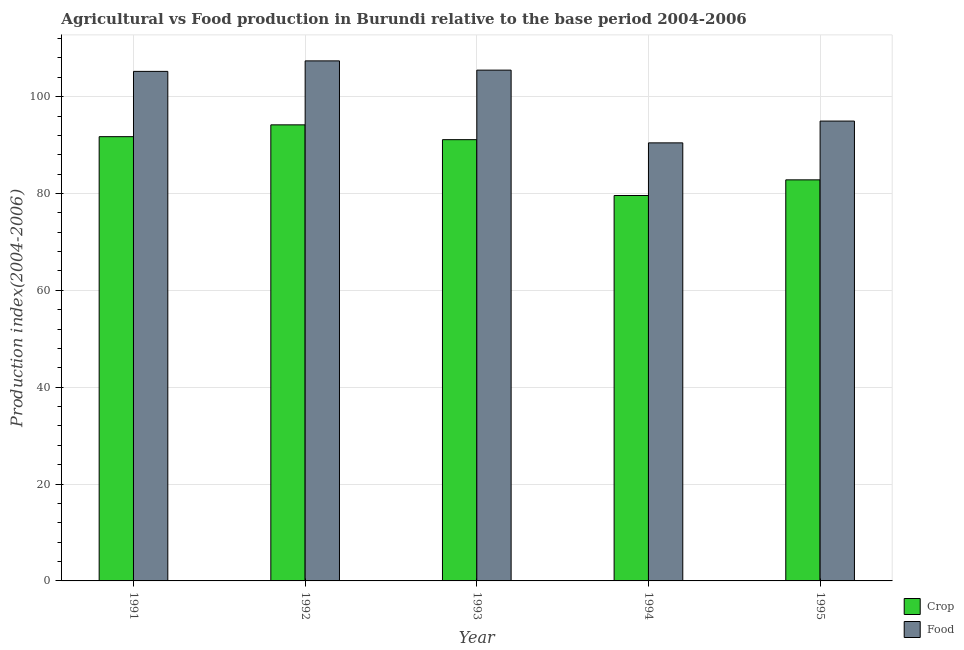How many different coloured bars are there?
Ensure brevity in your answer.  2. Are the number of bars per tick equal to the number of legend labels?
Offer a very short reply. Yes. Are the number of bars on each tick of the X-axis equal?
Provide a short and direct response. Yes. How many bars are there on the 1st tick from the right?
Provide a succinct answer. 2. What is the label of the 1st group of bars from the left?
Your response must be concise. 1991. What is the food production index in 1994?
Your answer should be very brief. 90.46. Across all years, what is the maximum crop production index?
Make the answer very short. 94.18. Across all years, what is the minimum food production index?
Offer a terse response. 90.46. In which year was the crop production index minimum?
Your response must be concise. 1994. What is the total crop production index in the graph?
Your answer should be very brief. 439.45. What is the difference between the crop production index in 1991 and that in 1994?
Provide a succinct answer. 12.15. What is the difference between the food production index in 1991 and the crop production index in 1993?
Give a very brief answer. -0.26. What is the average food production index per year?
Give a very brief answer. 100.7. In the year 1995, what is the difference between the crop production index and food production index?
Ensure brevity in your answer.  0. What is the ratio of the crop production index in 1992 to that in 1993?
Offer a terse response. 1.03. Is the difference between the crop production index in 1992 and 1994 greater than the difference between the food production index in 1992 and 1994?
Provide a succinct answer. No. What is the difference between the highest and the second highest food production index?
Your answer should be compact. 1.91. What is the difference between the highest and the lowest crop production index?
Give a very brief answer. 14.59. In how many years, is the food production index greater than the average food production index taken over all years?
Your answer should be compact. 3. What does the 1st bar from the left in 1991 represents?
Give a very brief answer. Crop. What does the 1st bar from the right in 1992 represents?
Your answer should be very brief. Food. Are all the bars in the graph horizontal?
Give a very brief answer. No. What is the difference between two consecutive major ticks on the Y-axis?
Your answer should be very brief. 20. Are the values on the major ticks of Y-axis written in scientific E-notation?
Give a very brief answer. No. Does the graph contain any zero values?
Ensure brevity in your answer.  No. Does the graph contain grids?
Offer a very short reply. Yes. Where does the legend appear in the graph?
Your answer should be very brief. Bottom right. How are the legend labels stacked?
Ensure brevity in your answer.  Vertical. What is the title of the graph?
Provide a succinct answer. Agricultural vs Food production in Burundi relative to the base period 2004-2006. What is the label or title of the X-axis?
Your answer should be very brief. Year. What is the label or title of the Y-axis?
Ensure brevity in your answer.  Production index(2004-2006). What is the Production index(2004-2006) in Crop in 1991?
Provide a short and direct response. 91.74. What is the Production index(2004-2006) of Food in 1991?
Keep it short and to the point. 105.22. What is the Production index(2004-2006) in Crop in 1992?
Your response must be concise. 94.18. What is the Production index(2004-2006) of Food in 1992?
Provide a succinct answer. 107.39. What is the Production index(2004-2006) of Crop in 1993?
Keep it short and to the point. 91.12. What is the Production index(2004-2006) in Food in 1993?
Ensure brevity in your answer.  105.48. What is the Production index(2004-2006) in Crop in 1994?
Give a very brief answer. 79.59. What is the Production index(2004-2006) in Food in 1994?
Ensure brevity in your answer.  90.46. What is the Production index(2004-2006) of Crop in 1995?
Provide a succinct answer. 82.82. What is the Production index(2004-2006) in Food in 1995?
Make the answer very short. 94.96. Across all years, what is the maximum Production index(2004-2006) in Crop?
Provide a short and direct response. 94.18. Across all years, what is the maximum Production index(2004-2006) of Food?
Keep it short and to the point. 107.39. Across all years, what is the minimum Production index(2004-2006) in Crop?
Provide a short and direct response. 79.59. Across all years, what is the minimum Production index(2004-2006) in Food?
Provide a succinct answer. 90.46. What is the total Production index(2004-2006) of Crop in the graph?
Offer a very short reply. 439.45. What is the total Production index(2004-2006) in Food in the graph?
Offer a very short reply. 503.51. What is the difference between the Production index(2004-2006) of Crop in 1991 and that in 1992?
Keep it short and to the point. -2.44. What is the difference between the Production index(2004-2006) of Food in 1991 and that in 1992?
Give a very brief answer. -2.17. What is the difference between the Production index(2004-2006) of Crop in 1991 and that in 1993?
Your answer should be compact. 0.62. What is the difference between the Production index(2004-2006) in Food in 1991 and that in 1993?
Offer a terse response. -0.26. What is the difference between the Production index(2004-2006) in Crop in 1991 and that in 1994?
Provide a short and direct response. 12.15. What is the difference between the Production index(2004-2006) of Food in 1991 and that in 1994?
Provide a succinct answer. 14.76. What is the difference between the Production index(2004-2006) in Crop in 1991 and that in 1995?
Your answer should be compact. 8.92. What is the difference between the Production index(2004-2006) in Food in 1991 and that in 1995?
Your answer should be very brief. 10.26. What is the difference between the Production index(2004-2006) of Crop in 1992 and that in 1993?
Your answer should be compact. 3.06. What is the difference between the Production index(2004-2006) of Food in 1992 and that in 1993?
Your answer should be compact. 1.91. What is the difference between the Production index(2004-2006) of Crop in 1992 and that in 1994?
Provide a short and direct response. 14.59. What is the difference between the Production index(2004-2006) in Food in 1992 and that in 1994?
Ensure brevity in your answer.  16.93. What is the difference between the Production index(2004-2006) of Crop in 1992 and that in 1995?
Provide a short and direct response. 11.36. What is the difference between the Production index(2004-2006) in Food in 1992 and that in 1995?
Give a very brief answer. 12.43. What is the difference between the Production index(2004-2006) of Crop in 1993 and that in 1994?
Your answer should be compact. 11.53. What is the difference between the Production index(2004-2006) in Food in 1993 and that in 1994?
Your answer should be compact. 15.02. What is the difference between the Production index(2004-2006) in Food in 1993 and that in 1995?
Your answer should be very brief. 10.52. What is the difference between the Production index(2004-2006) in Crop in 1994 and that in 1995?
Provide a succinct answer. -3.23. What is the difference between the Production index(2004-2006) of Crop in 1991 and the Production index(2004-2006) of Food in 1992?
Ensure brevity in your answer.  -15.65. What is the difference between the Production index(2004-2006) in Crop in 1991 and the Production index(2004-2006) in Food in 1993?
Offer a terse response. -13.74. What is the difference between the Production index(2004-2006) of Crop in 1991 and the Production index(2004-2006) of Food in 1994?
Provide a succinct answer. 1.28. What is the difference between the Production index(2004-2006) in Crop in 1991 and the Production index(2004-2006) in Food in 1995?
Ensure brevity in your answer.  -3.22. What is the difference between the Production index(2004-2006) in Crop in 1992 and the Production index(2004-2006) in Food in 1994?
Offer a very short reply. 3.72. What is the difference between the Production index(2004-2006) in Crop in 1992 and the Production index(2004-2006) in Food in 1995?
Provide a short and direct response. -0.78. What is the difference between the Production index(2004-2006) in Crop in 1993 and the Production index(2004-2006) in Food in 1994?
Provide a succinct answer. 0.66. What is the difference between the Production index(2004-2006) in Crop in 1993 and the Production index(2004-2006) in Food in 1995?
Your response must be concise. -3.84. What is the difference between the Production index(2004-2006) of Crop in 1994 and the Production index(2004-2006) of Food in 1995?
Your answer should be compact. -15.37. What is the average Production index(2004-2006) of Crop per year?
Provide a succinct answer. 87.89. What is the average Production index(2004-2006) in Food per year?
Your response must be concise. 100.7. In the year 1991, what is the difference between the Production index(2004-2006) in Crop and Production index(2004-2006) in Food?
Keep it short and to the point. -13.48. In the year 1992, what is the difference between the Production index(2004-2006) in Crop and Production index(2004-2006) in Food?
Provide a succinct answer. -13.21. In the year 1993, what is the difference between the Production index(2004-2006) in Crop and Production index(2004-2006) in Food?
Provide a succinct answer. -14.36. In the year 1994, what is the difference between the Production index(2004-2006) in Crop and Production index(2004-2006) in Food?
Provide a short and direct response. -10.87. In the year 1995, what is the difference between the Production index(2004-2006) in Crop and Production index(2004-2006) in Food?
Your response must be concise. -12.14. What is the ratio of the Production index(2004-2006) in Crop in 1991 to that in 1992?
Your answer should be compact. 0.97. What is the ratio of the Production index(2004-2006) of Food in 1991 to that in 1992?
Provide a succinct answer. 0.98. What is the ratio of the Production index(2004-2006) in Crop in 1991 to that in 1993?
Your response must be concise. 1.01. What is the ratio of the Production index(2004-2006) in Crop in 1991 to that in 1994?
Your answer should be very brief. 1.15. What is the ratio of the Production index(2004-2006) in Food in 1991 to that in 1994?
Provide a succinct answer. 1.16. What is the ratio of the Production index(2004-2006) of Crop in 1991 to that in 1995?
Keep it short and to the point. 1.11. What is the ratio of the Production index(2004-2006) in Food in 1991 to that in 1995?
Offer a terse response. 1.11. What is the ratio of the Production index(2004-2006) of Crop in 1992 to that in 1993?
Your response must be concise. 1.03. What is the ratio of the Production index(2004-2006) of Food in 1992 to that in 1993?
Your answer should be compact. 1.02. What is the ratio of the Production index(2004-2006) of Crop in 1992 to that in 1994?
Offer a very short reply. 1.18. What is the ratio of the Production index(2004-2006) in Food in 1992 to that in 1994?
Your answer should be compact. 1.19. What is the ratio of the Production index(2004-2006) in Crop in 1992 to that in 1995?
Ensure brevity in your answer.  1.14. What is the ratio of the Production index(2004-2006) in Food in 1992 to that in 1995?
Offer a very short reply. 1.13. What is the ratio of the Production index(2004-2006) of Crop in 1993 to that in 1994?
Provide a succinct answer. 1.14. What is the ratio of the Production index(2004-2006) in Food in 1993 to that in 1994?
Ensure brevity in your answer.  1.17. What is the ratio of the Production index(2004-2006) of Crop in 1993 to that in 1995?
Provide a short and direct response. 1.1. What is the ratio of the Production index(2004-2006) in Food in 1993 to that in 1995?
Offer a very short reply. 1.11. What is the ratio of the Production index(2004-2006) in Crop in 1994 to that in 1995?
Your response must be concise. 0.96. What is the ratio of the Production index(2004-2006) of Food in 1994 to that in 1995?
Keep it short and to the point. 0.95. What is the difference between the highest and the second highest Production index(2004-2006) in Crop?
Offer a terse response. 2.44. What is the difference between the highest and the second highest Production index(2004-2006) of Food?
Provide a short and direct response. 1.91. What is the difference between the highest and the lowest Production index(2004-2006) in Crop?
Provide a succinct answer. 14.59. What is the difference between the highest and the lowest Production index(2004-2006) in Food?
Your answer should be very brief. 16.93. 